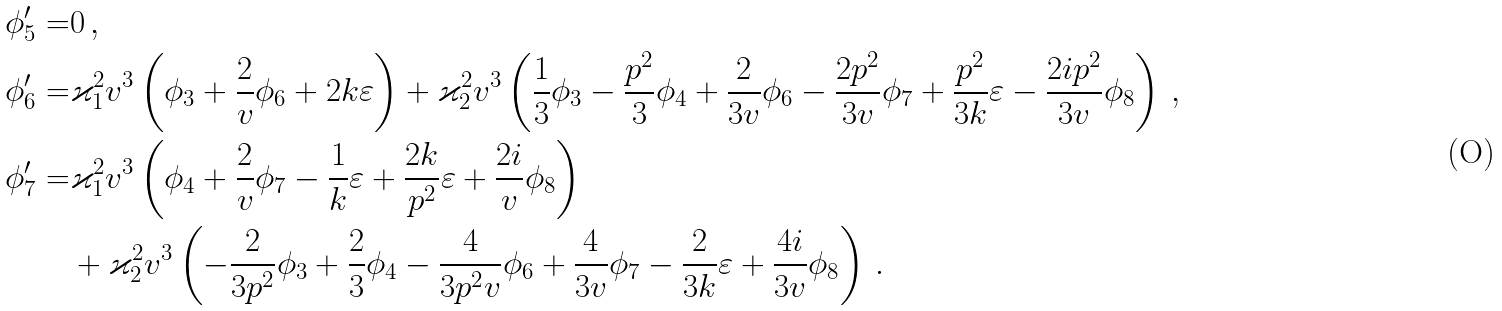<formula> <loc_0><loc_0><loc_500><loc_500>\phi _ { 5 } ^ { \prime } = & 0 \, , \\ \phi _ { 6 } ^ { \prime } = & \varkappa _ { 1 } ^ { 2 } v ^ { 3 } \left ( \phi _ { 3 } + \frac { 2 } { v } \phi _ { 6 } + 2 k \varepsilon \right ) + \varkappa _ { 2 } ^ { 2 } v ^ { 3 } \left ( \frac { 1 } { 3 } \phi _ { 3 } - \frac { { p } ^ { 2 } } { 3 } \phi _ { 4 } + \frac { 2 } { 3 v } \phi _ { 6 } - \frac { 2 { p } ^ { 2 } } { 3 v } \phi _ { 7 } + \frac { { p } ^ { 2 } } { 3 k } \varepsilon - \frac { 2 i { p } ^ { 2 } } { 3 v } \phi _ { 8 } \right ) \, , \\ \phi _ { 7 } ^ { \prime } = & \varkappa _ { 1 } ^ { 2 } v ^ { 3 } \left ( \phi _ { 4 } + \frac { 2 } { v } \phi _ { 7 } - \frac { 1 } { k } \varepsilon + \frac { 2 k } { { p } ^ { 2 } } \varepsilon + \frac { 2 i } { v } \phi _ { 8 } \right ) \\ & + \varkappa _ { 2 } ^ { 2 } v ^ { 3 } \left ( - \frac { 2 } { 3 { p } ^ { 2 } } \phi _ { 3 } + \frac { 2 } { 3 } \phi _ { 4 } - \frac { 4 } { 3 { p } ^ { 2 } v } \phi _ { 6 } + \frac { 4 } { 3 v } \phi _ { 7 } - \frac { 2 } { 3 k } \varepsilon + \frac { 4 i } { 3 v } \phi _ { 8 } \right ) \, .</formula> 